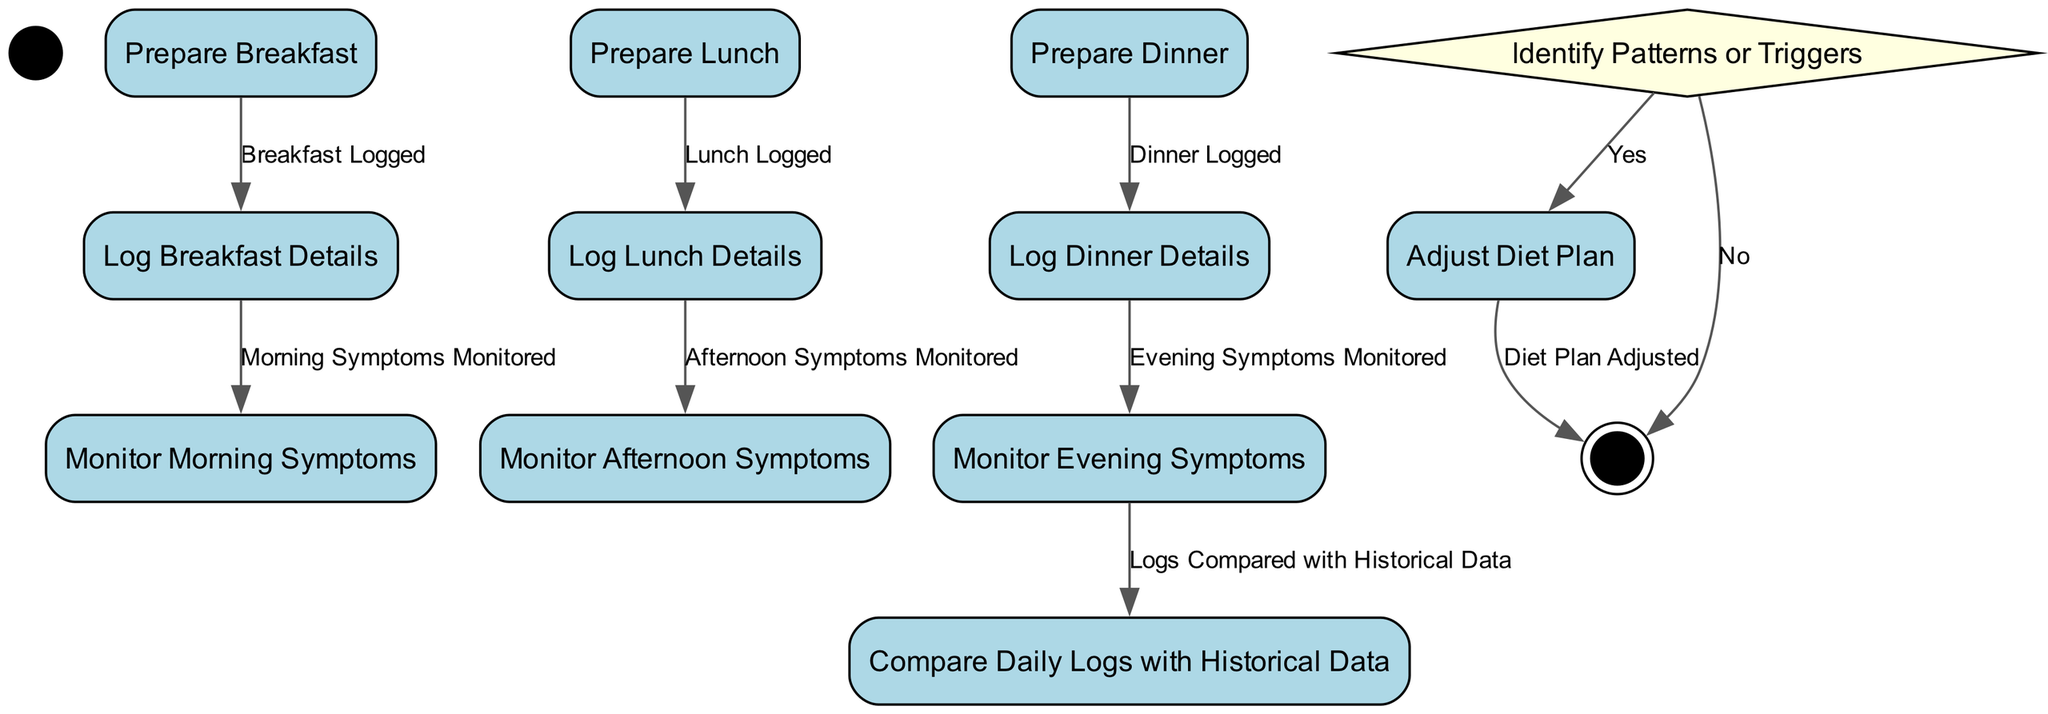What is the initial action in the diagram? The initial action node is labeled "Prepare Breakfast," which indicates that this is the first step in tracking the child's daily diet.
Answer: Prepare Breakfast How many action nodes are there in the diagram? By counting, there are six action nodes: "Prepare Breakfast," "Log Breakfast Details," "Prepare Lunch," "Log Lunch Details," "Prepare Dinner," and "Log Dinner Details."
Answer: Six What happens after "Log Lunch Details"? After "Log Lunch Details," the next action node is "Monitor Afternoon Symptoms," indicating the process flows into monitoring symptoms after logging lunch.
Answer: Monitor Afternoon Symptoms What is the decision point in the diagram? The decision point in the diagram is labeled "Identify Patterns or Triggers," which is where the parent assesses symptom patterns or food triggers.
Answer: Identify Patterns or Triggers If a pattern is identified, what is the next action? If a pattern is identified, the next action is "Adjust Diet Plan," where changes are made to the diet based on the findings.
Answer: Adjust Diet Plan What happens if no patterns or triggers are identified? If no patterns or triggers are identified, the process leads directly to the end of the tracking activity, indicating no changes are necessary.
Answer: End How many transitions are there from action nodes to symptom monitoring? There are three transitions from action nodes to symptom monitoring: one from "Log Breakfast Details" to "Monitor Morning Symptoms," one from "Log Lunch Details" to "Monitor Afternoon Symptoms," and one from "Log Dinner Details" to "Monitor Evening Symptoms."
Answer: Three What denotes the end of the tracking process? The process ends at the node labeled "End," which marks the conclusion of the diet and symptom tracking activity.
Answer: End 